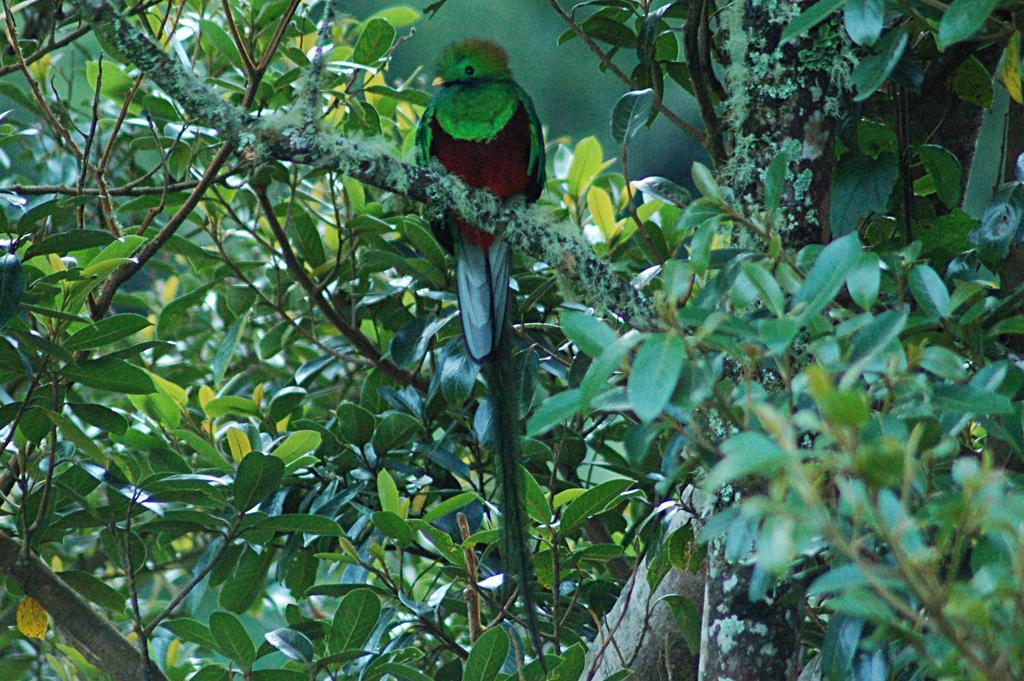How would you summarize this image in a sentence or two? In this picture I can see trees and a quetzal bird on the tree branch. 